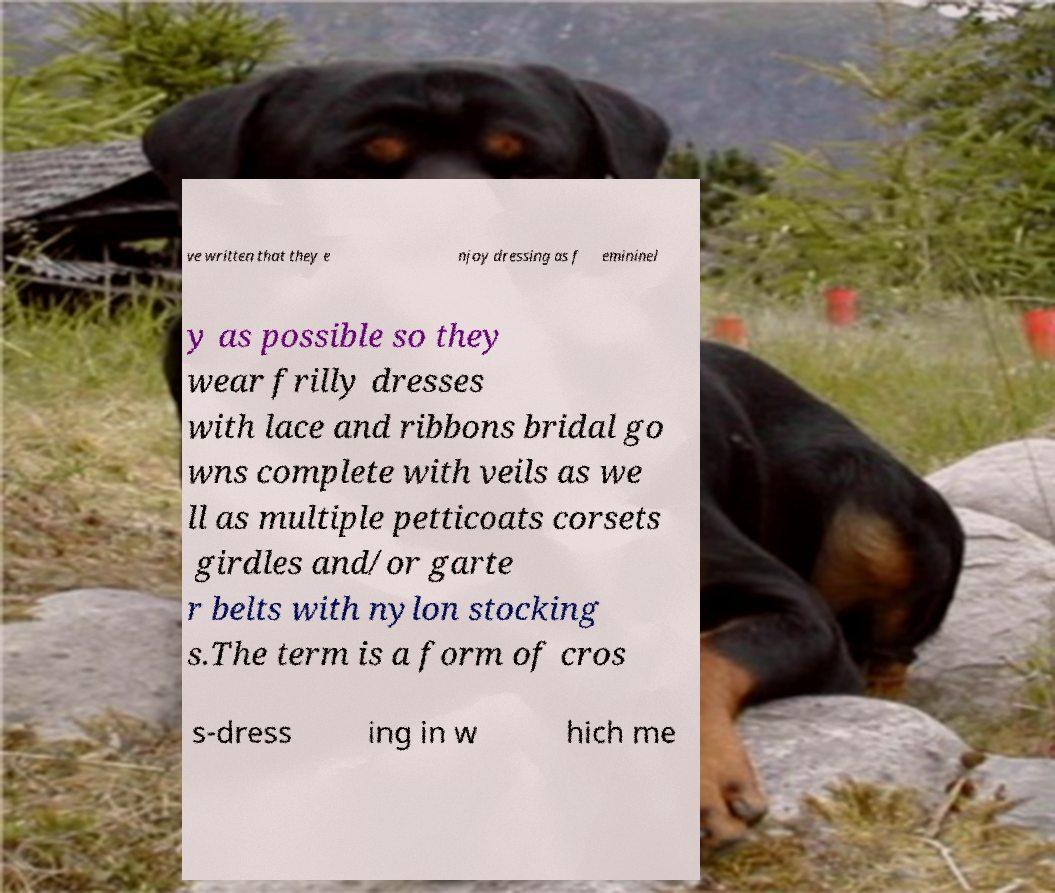Can you accurately transcribe the text from the provided image for me? ve written that they e njoy dressing as f emininel y as possible so they wear frilly dresses with lace and ribbons bridal go wns complete with veils as we ll as multiple petticoats corsets girdles and/or garte r belts with nylon stocking s.The term is a form of cros s-dress ing in w hich me 